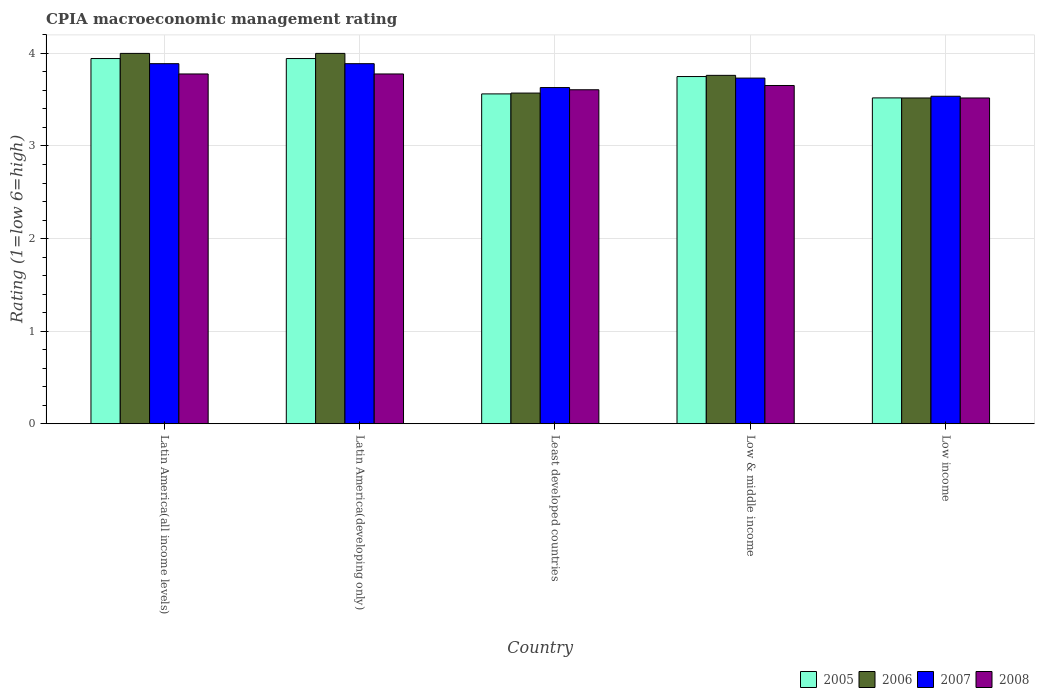How many groups of bars are there?
Provide a short and direct response. 5. Are the number of bars per tick equal to the number of legend labels?
Your answer should be compact. Yes. Are the number of bars on each tick of the X-axis equal?
Offer a very short reply. Yes. How many bars are there on the 1st tick from the left?
Your response must be concise. 4. What is the label of the 3rd group of bars from the left?
Your answer should be very brief. Least developed countries. In how many cases, is the number of bars for a given country not equal to the number of legend labels?
Your answer should be very brief. 0. What is the CPIA rating in 2007 in Low & middle income?
Your answer should be compact. 3.73. Across all countries, what is the maximum CPIA rating in 2008?
Your answer should be compact. 3.78. Across all countries, what is the minimum CPIA rating in 2008?
Your answer should be compact. 3.52. In which country was the CPIA rating in 2007 maximum?
Your response must be concise. Latin America(all income levels). In which country was the CPIA rating in 2008 minimum?
Your answer should be compact. Low income. What is the total CPIA rating in 2007 in the graph?
Provide a short and direct response. 18.68. What is the difference between the CPIA rating in 2006 in Least developed countries and that in Low & middle income?
Provide a succinct answer. -0.19. What is the difference between the CPIA rating in 2007 in Latin America(developing only) and the CPIA rating in 2005 in Least developed countries?
Your answer should be compact. 0.33. What is the average CPIA rating in 2007 per country?
Your answer should be compact. 3.74. What is the difference between the CPIA rating of/in 2006 and CPIA rating of/in 2005 in Low & middle income?
Your response must be concise. 0.01. What is the ratio of the CPIA rating in 2005 in Latin America(all income levels) to that in Low income?
Make the answer very short. 1.12. What is the difference between the highest and the second highest CPIA rating in 2005?
Your response must be concise. -0.19. What is the difference between the highest and the lowest CPIA rating in 2005?
Provide a succinct answer. 0.43. In how many countries, is the CPIA rating in 2005 greater than the average CPIA rating in 2005 taken over all countries?
Offer a terse response. 3. Is the sum of the CPIA rating in 2006 in Latin America(all income levels) and Latin America(developing only) greater than the maximum CPIA rating in 2005 across all countries?
Your answer should be very brief. Yes. Is it the case that in every country, the sum of the CPIA rating in 2005 and CPIA rating in 2008 is greater than the sum of CPIA rating in 2007 and CPIA rating in 2006?
Offer a terse response. No. What does the 1st bar from the left in Least developed countries represents?
Provide a succinct answer. 2005. What does the 3rd bar from the right in Low income represents?
Your response must be concise. 2006. Are all the bars in the graph horizontal?
Your answer should be compact. No. How many countries are there in the graph?
Make the answer very short. 5. Does the graph contain any zero values?
Give a very brief answer. No. Does the graph contain grids?
Keep it short and to the point. Yes. How many legend labels are there?
Keep it short and to the point. 4. What is the title of the graph?
Provide a short and direct response. CPIA macroeconomic management rating. What is the label or title of the Y-axis?
Provide a short and direct response. Rating (1=low 6=high). What is the Rating (1=low 6=high) of 2005 in Latin America(all income levels)?
Keep it short and to the point. 3.94. What is the Rating (1=low 6=high) of 2007 in Latin America(all income levels)?
Provide a short and direct response. 3.89. What is the Rating (1=low 6=high) in 2008 in Latin America(all income levels)?
Your answer should be compact. 3.78. What is the Rating (1=low 6=high) of 2005 in Latin America(developing only)?
Offer a very short reply. 3.94. What is the Rating (1=low 6=high) in 2007 in Latin America(developing only)?
Your answer should be compact. 3.89. What is the Rating (1=low 6=high) in 2008 in Latin America(developing only)?
Ensure brevity in your answer.  3.78. What is the Rating (1=low 6=high) in 2005 in Least developed countries?
Your response must be concise. 3.56. What is the Rating (1=low 6=high) in 2006 in Least developed countries?
Your answer should be very brief. 3.57. What is the Rating (1=low 6=high) in 2007 in Least developed countries?
Your response must be concise. 3.63. What is the Rating (1=low 6=high) of 2008 in Least developed countries?
Your response must be concise. 3.61. What is the Rating (1=low 6=high) in 2005 in Low & middle income?
Ensure brevity in your answer.  3.75. What is the Rating (1=low 6=high) in 2006 in Low & middle income?
Give a very brief answer. 3.76. What is the Rating (1=low 6=high) of 2007 in Low & middle income?
Your response must be concise. 3.73. What is the Rating (1=low 6=high) of 2008 in Low & middle income?
Keep it short and to the point. 3.65. What is the Rating (1=low 6=high) in 2005 in Low income?
Your answer should be compact. 3.52. What is the Rating (1=low 6=high) of 2006 in Low income?
Keep it short and to the point. 3.52. What is the Rating (1=low 6=high) of 2007 in Low income?
Ensure brevity in your answer.  3.54. What is the Rating (1=low 6=high) of 2008 in Low income?
Ensure brevity in your answer.  3.52. Across all countries, what is the maximum Rating (1=low 6=high) in 2005?
Provide a short and direct response. 3.94. Across all countries, what is the maximum Rating (1=low 6=high) in 2007?
Provide a short and direct response. 3.89. Across all countries, what is the maximum Rating (1=low 6=high) in 2008?
Your response must be concise. 3.78. Across all countries, what is the minimum Rating (1=low 6=high) of 2005?
Your response must be concise. 3.52. Across all countries, what is the minimum Rating (1=low 6=high) of 2006?
Provide a succinct answer. 3.52. Across all countries, what is the minimum Rating (1=low 6=high) of 2007?
Make the answer very short. 3.54. Across all countries, what is the minimum Rating (1=low 6=high) in 2008?
Your answer should be very brief. 3.52. What is the total Rating (1=low 6=high) in 2005 in the graph?
Provide a short and direct response. 18.72. What is the total Rating (1=low 6=high) of 2006 in the graph?
Your answer should be very brief. 18.85. What is the total Rating (1=low 6=high) in 2007 in the graph?
Provide a succinct answer. 18.68. What is the total Rating (1=low 6=high) of 2008 in the graph?
Your answer should be compact. 18.33. What is the difference between the Rating (1=low 6=high) of 2005 in Latin America(all income levels) and that in Latin America(developing only)?
Ensure brevity in your answer.  0. What is the difference between the Rating (1=low 6=high) in 2005 in Latin America(all income levels) and that in Least developed countries?
Your response must be concise. 0.38. What is the difference between the Rating (1=low 6=high) in 2006 in Latin America(all income levels) and that in Least developed countries?
Your response must be concise. 0.43. What is the difference between the Rating (1=low 6=high) in 2007 in Latin America(all income levels) and that in Least developed countries?
Give a very brief answer. 0.26. What is the difference between the Rating (1=low 6=high) of 2008 in Latin America(all income levels) and that in Least developed countries?
Make the answer very short. 0.17. What is the difference between the Rating (1=low 6=high) of 2005 in Latin America(all income levels) and that in Low & middle income?
Your answer should be compact. 0.19. What is the difference between the Rating (1=low 6=high) of 2006 in Latin America(all income levels) and that in Low & middle income?
Give a very brief answer. 0.24. What is the difference between the Rating (1=low 6=high) in 2007 in Latin America(all income levels) and that in Low & middle income?
Ensure brevity in your answer.  0.16. What is the difference between the Rating (1=low 6=high) in 2008 in Latin America(all income levels) and that in Low & middle income?
Provide a succinct answer. 0.12. What is the difference between the Rating (1=low 6=high) of 2005 in Latin America(all income levels) and that in Low income?
Your answer should be compact. 0.43. What is the difference between the Rating (1=low 6=high) in 2006 in Latin America(all income levels) and that in Low income?
Provide a short and direct response. 0.48. What is the difference between the Rating (1=low 6=high) of 2007 in Latin America(all income levels) and that in Low income?
Provide a succinct answer. 0.35. What is the difference between the Rating (1=low 6=high) of 2008 in Latin America(all income levels) and that in Low income?
Offer a very short reply. 0.26. What is the difference between the Rating (1=low 6=high) in 2005 in Latin America(developing only) and that in Least developed countries?
Your answer should be compact. 0.38. What is the difference between the Rating (1=low 6=high) in 2006 in Latin America(developing only) and that in Least developed countries?
Provide a succinct answer. 0.43. What is the difference between the Rating (1=low 6=high) in 2007 in Latin America(developing only) and that in Least developed countries?
Offer a terse response. 0.26. What is the difference between the Rating (1=low 6=high) of 2008 in Latin America(developing only) and that in Least developed countries?
Offer a very short reply. 0.17. What is the difference between the Rating (1=low 6=high) in 2005 in Latin America(developing only) and that in Low & middle income?
Provide a short and direct response. 0.19. What is the difference between the Rating (1=low 6=high) in 2006 in Latin America(developing only) and that in Low & middle income?
Your response must be concise. 0.24. What is the difference between the Rating (1=low 6=high) of 2007 in Latin America(developing only) and that in Low & middle income?
Your answer should be very brief. 0.16. What is the difference between the Rating (1=low 6=high) of 2008 in Latin America(developing only) and that in Low & middle income?
Ensure brevity in your answer.  0.12. What is the difference between the Rating (1=low 6=high) of 2005 in Latin America(developing only) and that in Low income?
Offer a very short reply. 0.43. What is the difference between the Rating (1=low 6=high) of 2006 in Latin America(developing only) and that in Low income?
Your answer should be very brief. 0.48. What is the difference between the Rating (1=low 6=high) in 2007 in Latin America(developing only) and that in Low income?
Your answer should be very brief. 0.35. What is the difference between the Rating (1=low 6=high) of 2008 in Latin America(developing only) and that in Low income?
Offer a very short reply. 0.26. What is the difference between the Rating (1=low 6=high) of 2005 in Least developed countries and that in Low & middle income?
Offer a terse response. -0.19. What is the difference between the Rating (1=low 6=high) in 2006 in Least developed countries and that in Low & middle income?
Make the answer very short. -0.19. What is the difference between the Rating (1=low 6=high) in 2007 in Least developed countries and that in Low & middle income?
Make the answer very short. -0.1. What is the difference between the Rating (1=low 6=high) in 2008 in Least developed countries and that in Low & middle income?
Your response must be concise. -0.05. What is the difference between the Rating (1=low 6=high) in 2005 in Least developed countries and that in Low income?
Make the answer very short. 0.04. What is the difference between the Rating (1=low 6=high) in 2006 in Least developed countries and that in Low income?
Your answer should be compact. 0.05. What is the difference between the Rating (1=low 6=high) of 2007 in Least developed countries and that in Low income?
Give a very brief answer. 0.09. What is the difference between the Rating (1=low 6=high) of 2008 in Least developed countries and that in Low income?
Give a very brief answer. 0.09. What is the difference between the Rating (1=low 6=high) of 2005 in Low & middle income and that in Low income?
Your answer should be very brief. 0.23. What is the difference between the Rating (1=low 6=high) in 2006 in Low & middle income and that in Low income?
Make the answer very short. 0.24. What is the difference between the Rating (1=low 6=high) in 2007 in Low & middle income and that in Low income?
Your answer should be compact. 0.2. What is the difference between the Rating (1=low 6=high) of 2008 in Low & middle income and that in Low income?
Provide a short and direct response. 0.13. What is the difference between the Rating (1=low 6=high) in 2005 in Latin America(all income levels) and the Rating (1=low 6=high) in 2006 in Latin America(developing only)?
Your answer should be very brief. -0.06. What is the difference between the Rating (1=low 6=high) in 2005 in Latin America(all income levels) and the Rating (1=low 6=high) in 2007 in Latin America(developing only)?
Ensure brevity in your answer.  0.06. What is the difference between the Rating (1=low 6=high) of 2005 in Latin America(all income levels) and the Rating (1=low 6=high) of 2008 in Latin America(developing only)?
Provide a succinct answer. 0.17. What is the difference between the Rating (1=low 6=high) in 2006 in Latin America(all income levels) and the Rating (1=low 6=high) in 2007 in Latin America(developing only)?
Your answer should be very brief. 0.11. What is the difference between the Rating (1=low 6=high) of 2006 in Latin America(all income levels) and the Rating (1=low 6=high) of 2008 in Latin America(developing only)?
Make the answer very short. 0.22. What is the difference between the Rating (1=low 6=high) in 2005 in Latin America(all income levels) and the Rating (1=low 6=high) in 2006 in Least developed countries?
Your answer should be compact. 0.37. What is the difference between the Rating (1=low 6=high) in 2005 in Latin America(all income levels) and the Rating (1=low 6=high) in 2007 in Least developed countries?
Make the answer very short. 0.31. What is the difference between the Rating (1=low 6=high) of 2005 in Latin America(all income levels) and the Rating (1=low 6=high) of 2008 in Least developed countries?
Ensure brevity in your answer.  0.34. What is the difference between the Rating (1=low 6=high) of 2006 in Latin America(all income levels) and the Rating (1=low 6=high) of 2007 in Least developed countries?
Provide a short and direct response. 0.37. What is the difference between the Rating (1=low 6=high) in 2006 in Latin America(all income levels) and the Rating (1=low 6=high) in 2008 in Least developed countries?
Keep it short and to the point. 0.39. What is the difference between the Rating (1=low 6=high) in 2007 in Latin America(all income levels) and the Rating (1=low 6=high) in 2008 in Least developed countries?
Provide a succinct answer. 0.28. What is the difference between the Rating (1=low 6=high) in 2005 in Latin America(all income levels) and the Rating (1=low 6=high) in 2006 in Low & middle income?
Your answer should be very brief. 0.18. What is the difference between the Rating (1=low 6=high) of 2005 in Latin America(all income levels) and the Rating (1=low 6=high) of 2007 in Low & middle income?
Your answer should be very brief. 0.21. What is the difference between the Rating (1=low 6=high) in 2005 in Latin America(all income levels) and the Rating (1=low 6=high) in 2008 in Low & middle income?
Offer a terse response. 0.29. What is the difference between the Rating (1=low 6=high) in 2006 in Latin America(all income levels) and the Rating (1=low 6=high) in 2007 in Low & middle income?
Provide a short and direct response. 0.27. What is the difference between the Rating (1=low 6=high) in 2006 in Latin America(all income levels) and the Rating (1=low 6=high) in 2008 in Low & middle income?
Your response must be concise. 0.35. What is the difference between the Rating (1=low 6=high) of 2007 in Latin America(all income levels) and the Rating (1=low 6=high) of 2008 in Low & middle income?
Provide a succinct answer. 0.24. What is the difference between the Rating (1=low 6=high) in 2005 in Latin America(all income levels) and the Rating (1=low 6=high) in 2006 in Low income?
Your response must be concise. 0.43. What is the difference between the Rating (1=low 6=high) of 2005 in Latin America(all income levels) and the Rating (1=low 6=high) of 2007 in Low income?
Your response must be concise. 0.41. What is the difference between the Rating (1=low 6=high) in 2005 in Latin America(all income levels) and the Rating (1=low 6=high) in 2008 in Low income?
Give a very brief answer. 0.43. What is the difference between the Rating (1=low 6=high) of 2006 in Latin America(all income levels) and the Rating (1=low 6=high) of 2007 in Low income?
Provide a succinct answer. 0.46. What is the difference between the Rating (1=low 6=high) of 2006 in Latin America(all income levels) and the Rating (1=low 6=high) of 2008 in Low income?
Offer a terse response. 0.48. What is the difference between the Rating (1=low 6=high) of 2007 in Latin America(all income levels) and the Rating (1=low 6=high) of 2008 in Low income?
Make the answer very short. 0.37. What is the difference between the Rating (1=low 6=high) of 2005 in Latin America(developing only) and the Rating (1=low 6=high) of 2006 in Least developed countries?
Give a very brief answer. 0.37. What is the difference between the Rating (1=low 6=high) in 2005 in Latin America(developing only) and the Rating (1=low 6=high) in 2007 in Least developed countries?
Your response must be concise. 0.31. What is the difference between the Rating (1=low 6=high) in 2005 in Latin America(developing only) and the Rating (1=low 6=high) in 2008 in Least developed countries?
Your answer should be very brief. 0.34. What is the difference between the Rating (1=low 6=high) in 2006 in Latin America(developing only) and the Rating (1=low 6=high) in 2007 in Least developed countries?
Give a very brief answer. 0.37. What is the difference between the Rating (1=low 6=high) in 2006 in Latin America(developing only) and the Rating (1=low 6=high) in 2008 in Least developed countries?
Make the answer very short. 0.39. What is the difference between the Rating (1=low 6=high) of 2007 in Latin America(developing only) and the Rating (1=low 6=high) of 2008 in Least developed countries?
Your response must be concise. 0.28. What is the difference between the Rating (1=low 6=high) of 2005 in Latin America(developing only) and the Rating (1=low 6=high) of 2006 in Low & middle income?
Offer a terse response. 0.18. What is the difference between the Rating (1=low 6=high) of 2005 in Latin America(developing only) and the Rating (1=low 6=high) of 2007 in Low & middle income?
Provide a succinct answer. 0.21. What is the difference between the Rating (1=low 6=high) in 2005 in Latin America(developing only) and the Rating (1=low 6=high) in 2008 in Low & middle income?
Offer a terse response. 0.29. What is the difference between the Rating (1=low 6=high) of 2006 in Latin America(developing only) and the Rating (1=low 6=high) of 2007 in Low & middle income?
Ensure brevity in your answer.  0.27. What is the difference between the Rating (1=low 6=high) in 2006 in Latin America(developing only) and the Rating (1=low 6=high) in 2008 in Low & middle income?
Ensure brevity in your answer.  0.35. What is the difference between the Rating (1=low 6=high) of 2007 in Latin America(developing only) and the Rating (1=low 6=high) of 2008 in Low & middle income?
Keep it short and to the point. 0.24. What is the difference between the Rating (1=low 6=high) of 2005 in Latin America(developing only) and the Rating (1=low 6=high) of 2006 in Low income?
Ensure brevity in your answer.  0.43. What is the difference between the Rating (1=low 6=high) in 2005 in Latin America(developing only) and the Rating (1=low 6=high) in 2007 in Low income?
Offer a terse response. 0.41. What is the difference between the Rating (1=low 6=high) of 2005 in Latin America(developing only) and the Rating (1=low 6=high) of 2008 in Low income?
Provide a succinct answer. 0.43. What is the difference between the Rating (1=low 6=high) in 2006 in Latin America(developing only) and the Rating (1=low 6=high) in 2007 in Low income?
Offer a very short reply. 0.46. What is the difference between the Rating (1=low 6=high) of 2006 in Latin America(developing only) and the Rating (1=low 6=high) of 2008 in Low income?
Ensure brevity in your answer.  0.48. What is the difference between the Rating (1=low 6=high) of 2007 in Latin America(developing only) and the Rating (1=low 6=high) of 2008 in Low income?
Offer a very short reply. 0.37. What is the difference between the Rating (1=low 6=high) of 2005 in Least developed countries and the Rating (1=low 6=high) of 2006 in Low & middle income?
Your answer should be very brief. -0.2. What is the difference between the Rating (1=low 6=high) in 2005 in Least developed countries and the Rating (1=low 6=high) in 2007 in Low & middle income?
Make the answer very short. -0.17. What is the difference between the Rating (1=low 6=high) in 2005 in Least developed countries and the Rating (1=low 6=high) in 2008 in Low & middle income?
Give a very brief answer. -0.09. What is the difference between the Rating (1=low 6=high) in 2006 in Least developed countries and the Rating (1=low 6=high) in 2007 in Low & middle income?
Your answer should be compact. -0.16. What is the difference between the Rating (1=low 6=high) in 2006 in Least developed countries and the Rating (1=low 6=high) in 2008 in Low & middle income?
Ensure brevity in your answer.  -0.08. What is the difference between the Rating (1=low 6=high) of 2007 in Least developed countries and the Rating (1=low 6=high) of 2008 in Low & middle income?
Your response must be concise. -0.02. What is the difference between the Rating (1=low 6=high) in 2005 in Least developed countries and the Rating (1=low 6=high) in 2006 in Low income?
Make the answer very short. 0.04. What is the difference between the Rating (1=low 6=high) of 2005 in Least developed countries and the Rating (1=low 6=high) of 2007 in Low income?
Provide a succinct answer. 0.03. What is the difference between the Rating (1=low 6=high) in 2005 in Least developed countries and the Rating (1=low 6=high) in 2008 in Low income?
Offer a very short reply. 0.04. What is the difference between the Rating (1=low 6=high) of 2006 in Least developed countries and the Rating (1=low 6=high) of 2007 in Low income?
Your response must be concise. 0.03. What is the difference between the Rating (1=low 6=high) of 2006 in Least developed countries and the Rating (1=low 6=high) of 2008 in Low income?
Make the answer very short. 0.05. What is the difference between the Rating (1=low 6=high) of 2007 in Least developed countries and the Rating (1=low 6=high) of 2008 in Low income?
Make the answer very short. 0.11. What is the difference between the Rating (1=low 6=high) in 2005 in Low & middle income and the Rating (1=low 6=high) in 2006 in Low income?
Offer a very short reply. 0.23. What is the difference between the Rating (1=low 6=high) in 2005 in Low & middle income and the Rating (1=low 6=high) in 2007 in Low income?
Offer a terse response. 0.21. What is the difference between the Rating (1=low 6=high) in 2005 in Low & middle income and the Rating (1=low 6=high) in 2008 in Low income?
Your answer should be compact. 0.23. What is the difference between the Rating (1=low 6=high) in 2006 in Low & middle income and the Rating (1=low 6=high) in 2007 in Low income?
Ensure brevity in your answer.  0.23. What is the difference between the Rating (1=low 6=high) of 2006 in Low & middle income and the Rating (1=low 6=high) of 2008 in Low income?
Provide a short and direct response. 0.24. What is the difference between the Rating (1=low 6=high) in 2007 in Low & middle income and the Rating (1=low 6=high) in 2008 in Low income?
Your response must be concise. 0.21. What is the average Rating (1=low 6=high) in 2005 per country?
Provide a succinct answer. 3.74. What is the average Rating (1=low 6=high) of 2006 per country?
Keep it short and to the point. 3.77. What is the average Rating (1=low 6=high) of 2007 per country?
Keep it short and to the point. 3.74. What is the average Rating (1=low 6=high) of 2008 per country?
Your answer should be compact. 3.67. What is the difference between the Rating (1=low 6=high) of 2005 and Rating (1=low 6=high) of 2006 in Latin America(all income levels)?
Ensure brevity in your answer.  -0.06. What is the difference between the Rating (1=low 6=high) in 2005 and Rating (1=low 6=high) in 2007 in Latin America(all income levels)?
Give a very brief answer. 0.06. What is the difference between the Rating (1=low 6=high) in 2006 and Rating (1=low 6=high) in 2008 in Latin America(all income levels)?
Provide a succinct answer. 0.22. What is the difference between the Rating (1=low 6=high) of 2005 and Rating (1=low 6=high) of 2006 in Latin America(developing only)?
Your answer should be very brief. -0.06. What is the difference between the Rating (1=low 6=high) of 2005 and Rating (1=low 6=high) of 2007 in Latin America(developing only)?
Your answer should be compact. 0.06. What is the difference between the Rating (1=low 6=high) in 2006 and Rating (1=low 6=high) in 2007 in Latin America(developing only)?
Keep it short and to the point. 0.11. What is the difference between the Rating (1=low 6=high) of 2006 and Rating (1=low 6=high) of 2008 in Latin America(developing only)?
Offer a very short reply. 0.22. What is the difference between the Rating (1=low 6=high) in 2005 and Rating (1=low 6=high) in 2006 in Least developed countries?
Provide a short and direct response. -0.01. What is the difference between the Rating (1=low 6=high) in 2005 and Rating (1=low 6=high) in 2007 in Least developed countries?
Make the answer very short. -0.07. What is the difference between the Rating (1=low 6=high) of 2005 and Rating (1=low 6=high) of 2008 in Least developed countries?
Offer a very short reply. -0.04. What is the difference between the Rating (1=low 6=high) in 2006 and Rating (1=low 6=high) in 2007 in Least developed countries?
Give a very brief answer. -0.06. What is the difference between the Rating (1=low 6=high) in 2006 and Rating (1=low 6=high) in 2008 in Least developed countries?
Provide a short and direct response. -0.04. What is the difference between the Rating (1=low 6=high) in 2007 and Rating (1=low 6=high) in 2008 in Least developed countries?
Provide a short and direct response. 0.02. What is the difference between the Rating (1=low 6=high) of 2005 and Rating (1=low 6=high) of 2006 in Low & middle income?
Keep it short and to the point. -0.01. What is the difference between the Rating (1=low 6=high) in 2005 and Rating (1=low 6=high) in 2007 in Low & middle income?
Your answer should be compact. 0.02. What is the difference between the Rating (1=low 6=high) of 2005 and Rating (1=low 6=high) of 2008 in Low & middle income?
Keep it short and to the point. 0.1. What is the difference between the Rating (1=low 6=high) in 2006 and Rating (1=low 6=high) in 2007 in Low & middle income?
Your response must be concise. 0.03. What is the difference between the Rating (1=low 6=high) of 2006 and Rating (1=low 6=high) of 2008 in Low & middle income?
Your answer should be compact. 0.11. What is the difference between the Rating (1=low 6=high) of 2007 and Rating (1=low 6=high) of 2008 in Low & middle income?
Give a very brief answer. 0.08. What is the difference between the Rating (1=low 6=high) of 2005 and Rating (1=low 6=high) of 2006 in Low income?
Provide a short and direct response. 0. What is the difference between the Rating (1=low 6=high) in 2005 and Rating (1=low 6=high) in 2007 in Low income?
Ensure brevity in your answer.  -0.02. What is the difference between the Rating (1=low 6=high) of 2005 and Rating (1=low 6=high) of 2008 in Low income?
Offer a terse response. 0. What is the difference between the Rating (1=low 6=high) of 2006 and Rating (1=low 6=high) of 2007 in Low income?
Ensure brevity in your answer.  -0.02. What is the difference between the Rating (1=low 6=high) of 2006 and Rating (1=low 6=high) of 2008 in Low income?
Provide a succinct answer. 0. What is the difference between the Rating (1=low 6=high) of 2007 and Rating (1=low 6=high) of 2008 in Low income?
Make the answer very short. 0.02. What is the ratio of the Rating (1=low 6=high) in 2006 in Latin America(all income levels) to that in Latin America(developing only)?
Your answer should be compact. 1. What is the ratio of the Rating (1=low 6=high) in 2007 in Latin America(all income levels) to that in Latin America(developing only)?
Give a very brief answer. 1. What is the ratio of the Rating (1=low 6=high) in 2005 in Latin America(all income levels) to that in Least developed countries?
Make the answer very short. 1.11. What is the ratio of the Rating (1=low 6=high) of 2006 in Latin America(all income levels) to that in Least developed countries?
Your answer should be very brief. 1.12. What is the ratio of the Rating (1=low 6=high) of 2007 in Latin America(all income levels) to that in Least developed countries?
Provide a short and direct response. 1.07. What is the ratio of the Rating (1=low 6=high) in 2008 in Latin America(all income levels) to that in Least developed countries?
Your answer should be very brief. 1.05. What is the ratio of the Rating (1=low 6=high) of 2005 in Latin America(all income levels) to that in Low & middle income?
Make the answer very short. 1.05. What is the ratio of the Rating (1=low 6=high) in 2006 in Latin America(all income levels) to that in Low & middle income?
Your response must be concise. 1.06. What is the ratio of the Rating (1=low 6=high) of 2007 in Latin America(all income levels) to that in Low & middle income?
Your answer should be compact. 1.04. What is the ratio of the Rating (1=low 6=high) in 2008 in Latin America(all income levels) to that in Low & middle income?
Your answer should be very brief. 1.03. What is the ratio of the Rating (1=low 6=high) in 2005 in Latin America(all income levels) to that in Low income?
Offer a terse response. 1.12. What is the ratio of the Rating (1=low 6=high) of 2006 in Latin America(all income levels) to that in Low income?
Your answer should be compact. 1.14. What is the ratio of the Rating (1=low 6=high) of 2007 in Latin America(all income levels) to that in Low income?
Your answer should be very brief. 1.1. What is the ratio of the Rating (1=low 6=high) of 2008 in Latin America(all income levels) to that in Low income?
Give a very brief answer. 1.07. What is the ratio of the Rating (1=low 6=high) of 2005 in Latin America(developing only) to that in Least developed countries?
Your answer should be very brief. 1.11. What is the ratio of the Rating (1=low 6=high) of 2006 in Latin America(developing only) to that in Least developed countries?
Keep it short and to the point. 1.12. What is the ratio of the Rating (1=low 6=high) of 2007 in Latin America(developing only) to that in Least developed countries?
Offer a very short reply. 1.07. What is the ratio of the Rating (1=low 6=high) in 2008 in Latin America(developing only) to that in Least developed countries?
Your answer should be compact. 1.05. What is the ratio of the Rating (1=low 6=high) in 2005 in Latin America(developing only) to that in Low & middle income?
Your answer should be very brief. 1.05. What is the ratio of the Rating (1=low 6=high) of 2006 in Latin America(developing only) to that in Low & middle income?
Ensure brevity in your answer.  1.06. What is the ratio of the Rating (1=low 6=high) in 2007 in Latin America(developing only) to that in Low & middle income?
Keep it short and to the point. 1.04. What is the ratio of the Rating (1=low 6=high) in 2008 in Latin America(developing only) to that in Low & middle income?
Provide a succinct answer. 1.03. What is the ratio of the Rating (1=low 6=high) in 2005 in Latin America(developing only) to that in Low income?
Provide a short and direct response. 1.12. What is the ratio of the Rating (1=low 6=high) in 2006 in Latin America(developing only) to that in Low income?
Ensure brevity in your answer.  1.14. What is the ratio of the Rating (1=low 6=high) in 2007 in Latin America(developing only) to that in Low income?
Offer a very short reply. 1.1. What is the ratio of the Rating (1=low 6=high) of 2008 in Latin America(developing only) to that in Low income?
Ensure brevity in your answer.  1.07. What is the ratio of the Rating (1=low 6=high) in 2006 in Least developed countries to that in Low & middle income?
Offer a very short reply. 0.95. What is the ratio of the Rating (1=low 6=high) in 2007 in Least developed countries to that in Low & middle income?
Your answer should be compact. 0.97. What is the ratio of the Rating (1=low 6=high) in 2008 in Least developed countries to that in Low & middle income?
Your answer should be compact. 0.99. What is the ratio of the Rating (1=low 6=high) in 2005 in Least developed countries to that in Low income?
Provide a succinct answer. 1.01. What is the ratio of the Rating (1=low 6=high) of 2006 in Least developed countries to that in Low income?
Your answer should be compact. 1.01. What is the ratio of the Rating (1=low 6=high) of 2007 in Least developed countries to that in Low income?
Provide a succinct answer. 1.03. What is the ratio of the Rating (1=low 6=high) in 2008 in Least developed countries to that in Low income?
Provide a short and direct response. 1.03. What is the ratio of the Rating (1=low 6=high) in 2005 in Low & middle income to that in Low income?
Your response must be concise. 1.07. What is the ratio of the Rating (1=low 6=high) of 2006 in Low & middle income to that in Low income?
Offer a very short reply. 1.07. What is the ratio of the Rating (1=low 6=high) of 2007 in Low & middle income to that in Low income?
Your response must be concise. 1.06. What is the ratio of the Rating (1=low 6=high) of 2008 in Low & middle income to that in Low income?
Provide a succinct answer. 1.04. What is the difference between the highest and the second highest Rating (1=low 6=high) in 2007?
Offer a terse response. 0. What is the difference between the highest and the lowest Rating (1=low 6=high) in 2005?
Give a very brief answer. 0.43. What is the difference between the highest and the lowest Rating (1=low 6=high) of 2006?
Provide a short and direct response. 0.48. What is the difference between the highest and the lowest Rating (1=low 6=high) in 2007?
Your answer should be very brief. 0.35. What is the difference between the highest and the lowest Rating (1=low 6=high) of 2008?
Offer a very short reply. 0.26. 